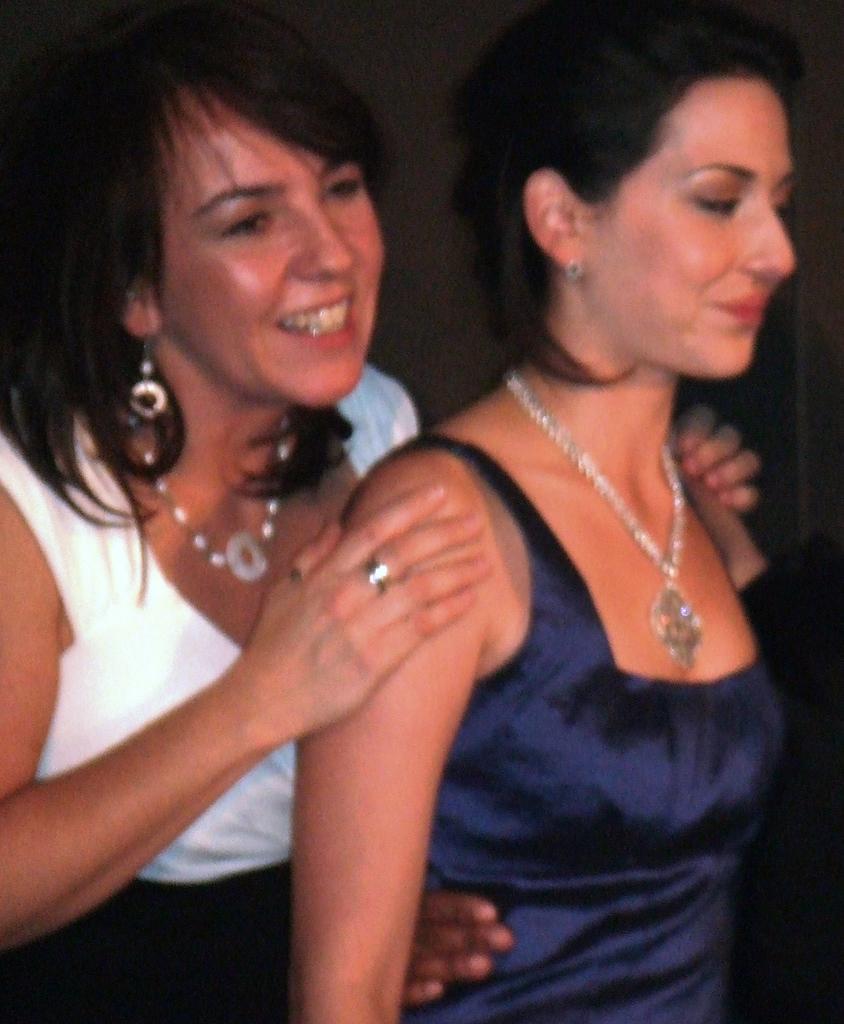Can you describe this image briefly? In this image there are two ladies standing, in the background it is dark. 